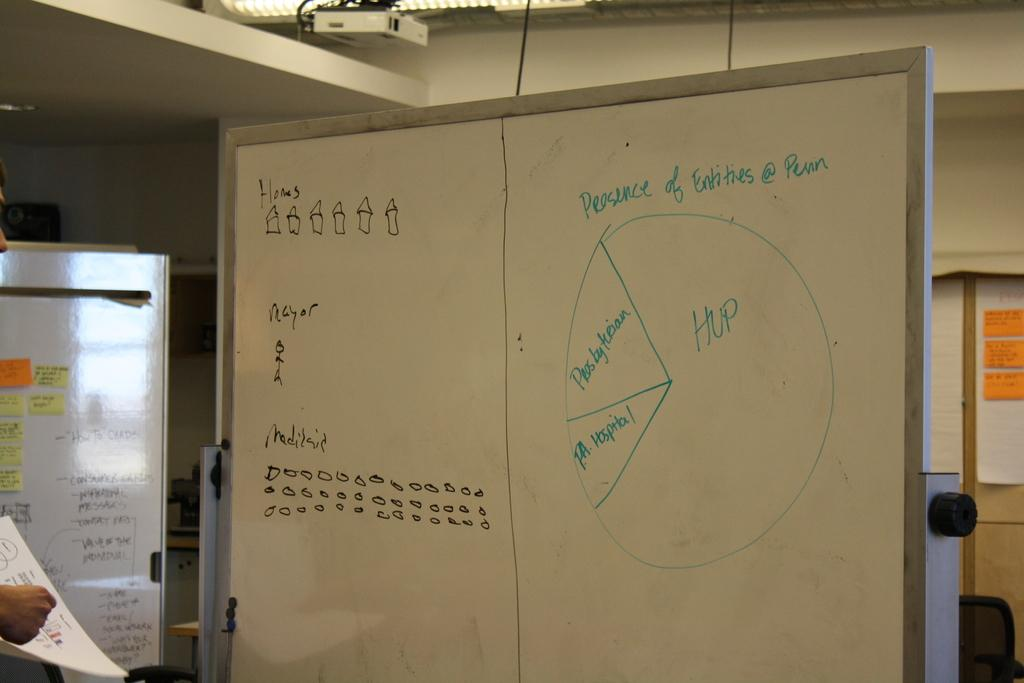<image>
Summarize the visual content of the image. A whiteboard has a pie chart with the heading Presence of Entities @ Penn. 